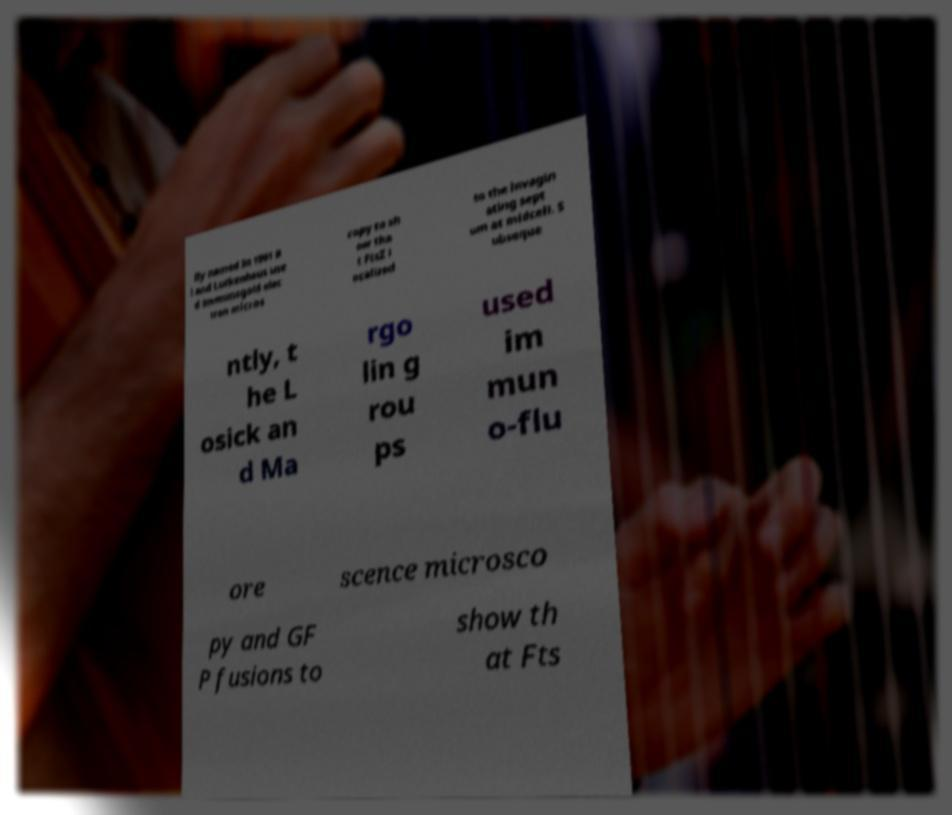Please read and relay the text visible in this image. What does it say? lly named In 1991 B i and Lutkenhaus use d immunogold elec tron micros copy to sh ow tha t FtsZ l ocalized to the invagin ating sept um at midcell. S ubseque ntly, t he L osick an d Ma rgo lin g rou ps used im mun o-flu ore scence microsco py and GF P fusions to show th at Fts 